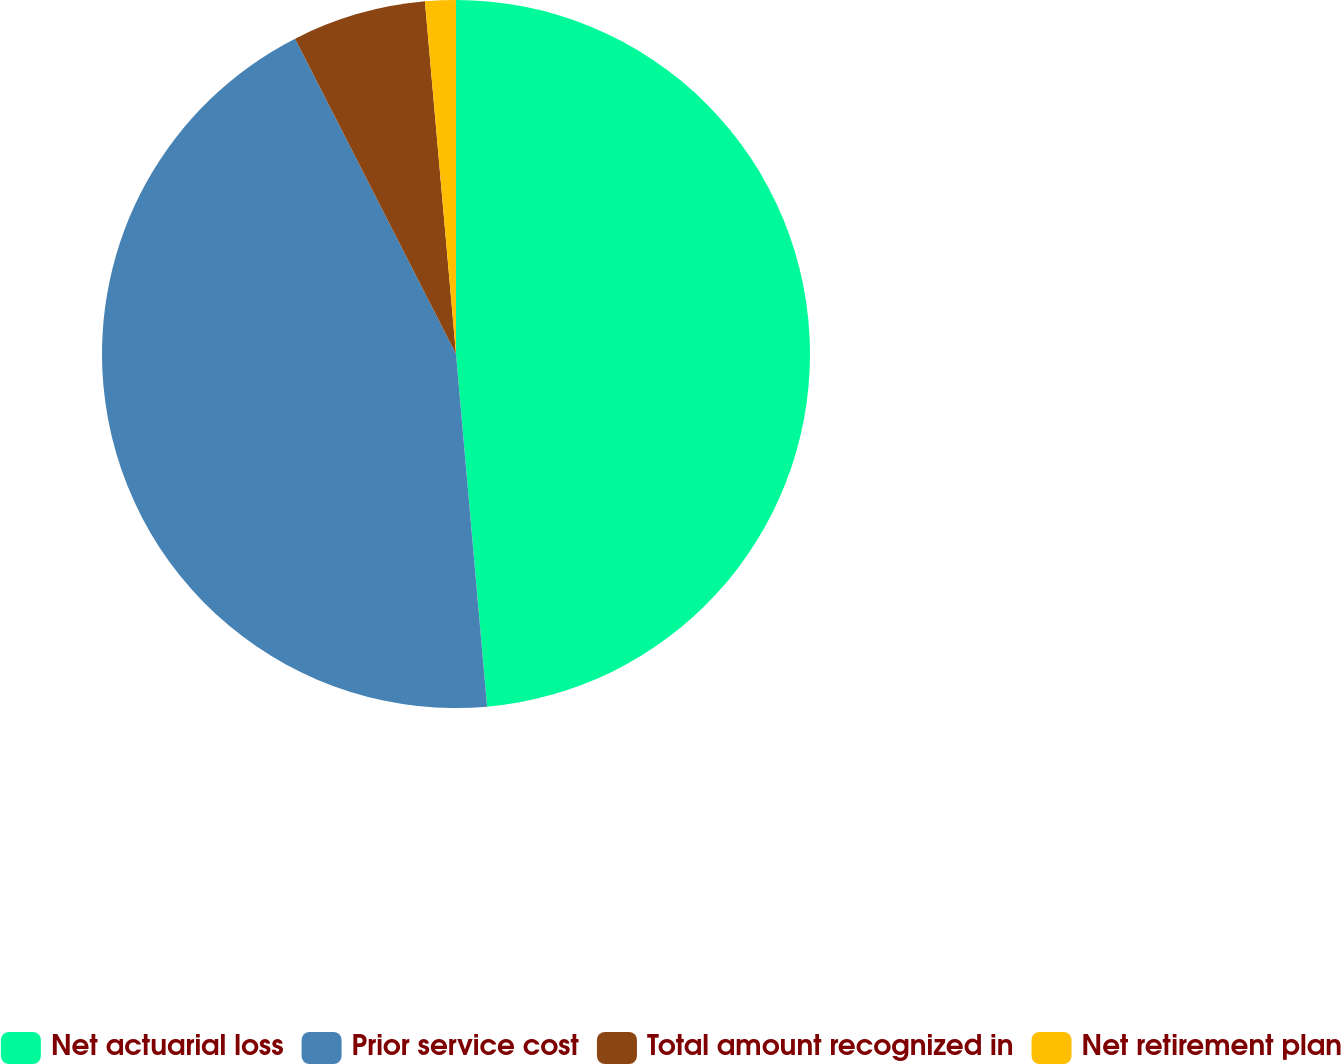Convert chart. <chart><loc_0><loc_0><loc_500><loc_500><pie_chart><fcel>Net actuarial loss<fcel>Prior service cost<fcel>Total amount recognized in<fcel>Net retirement plan<nl><fcel>48.6%<fcel>43.89%<fcel>6.11%<fcel>1.4%<nl></chart> 